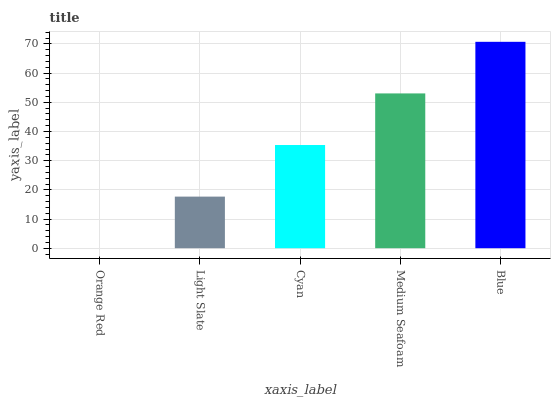Is Light Slate the minimum?
Answer yes or no. No. Is Light Slate the maximum?
Answer yes or no. No. Is Light Slate greater than Orange Red?
Answer yes or no. Yes. Is Orange Red less than Light Slate?
Answer yes or no. Yes. Is Orange Red greater than Light Slate?
Answer yes or no. No. Is Light Slate less than Orange Red?
Answer yes or no. No. Is Cyan the high median?
Answer yes or no. Yes. Is Cyan the low median?
Answer yes or no. Yes. Is Medium Seafoam the high median?
Answer yes or no. No. Is Blue the low median?
Answer yes or no. No. 